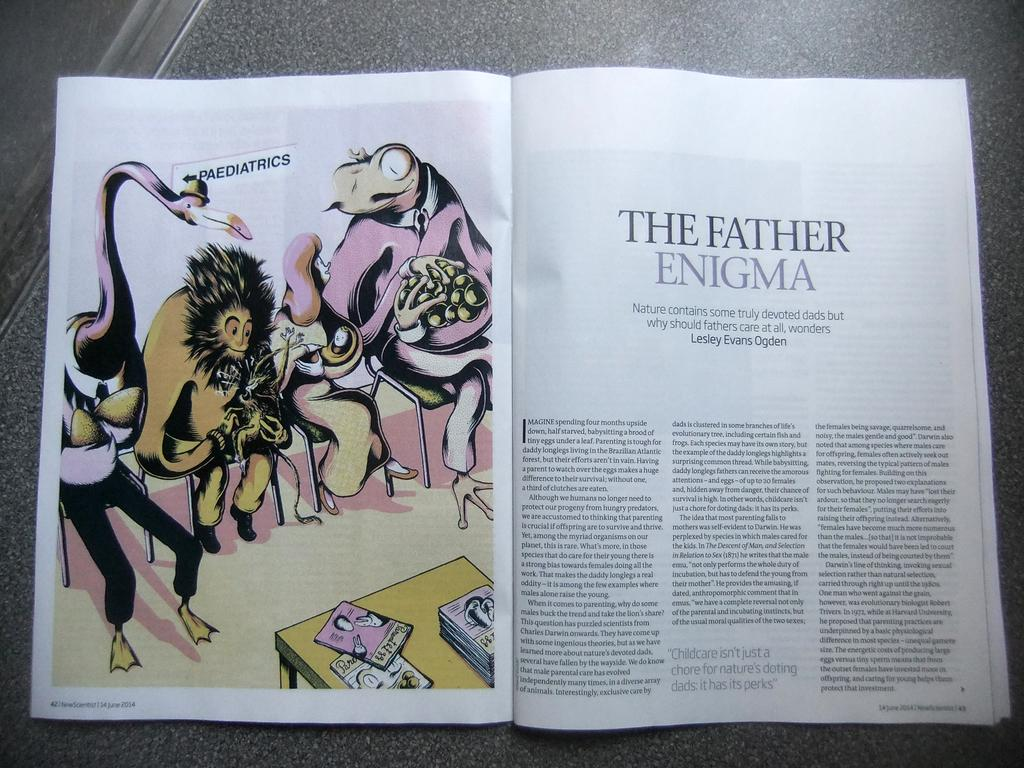Provide a one-sentence caption for the provided image. A magazine opened to an article entitled The Father Enigma with an illustration on the left side of the page. 